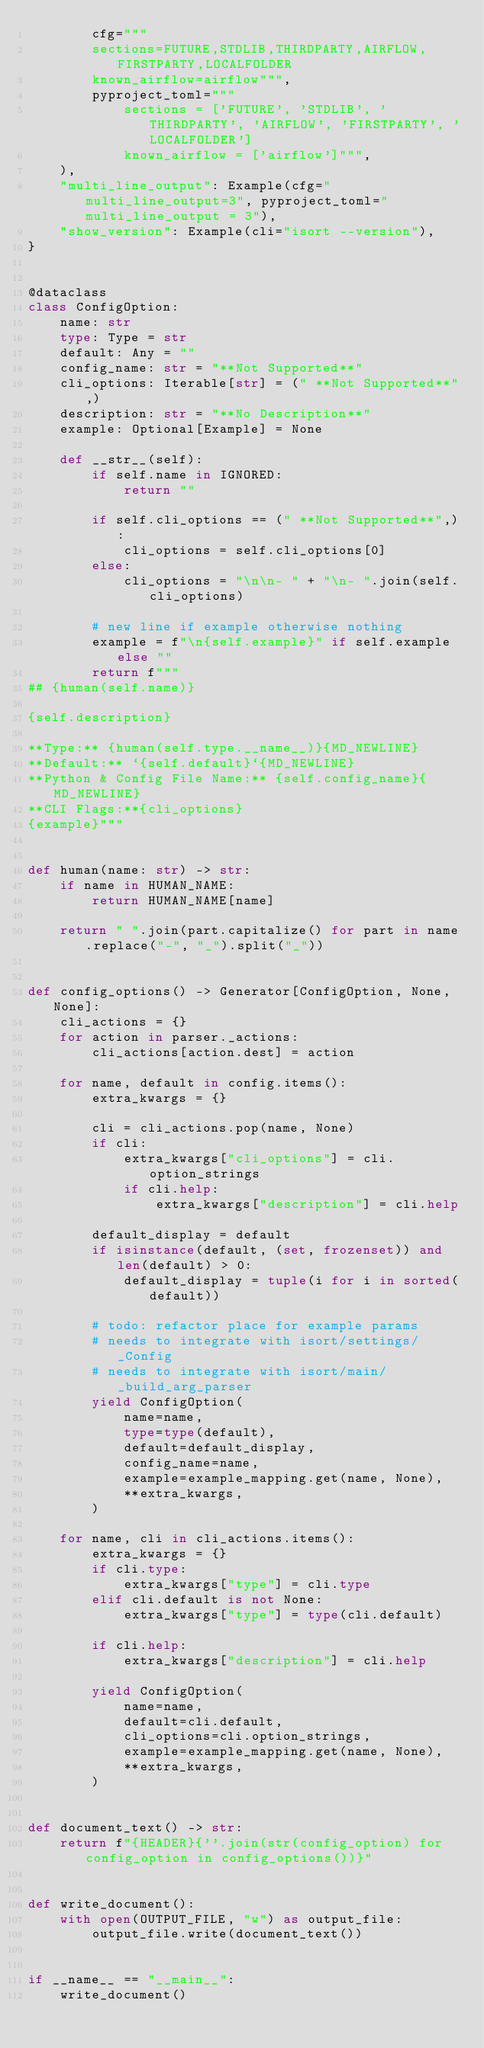<code> <loc_0><loc_0><loc_500><loc_500><_Python_>        cfg="""
        sections=FUTURE,STDLIB,THIRDPARTY,AIRFLOW,FIRSTPARTY,LOCALFOLDER
        known_airflow=airflow""",
        pyproject_toml="""
            sections = ['FUTURE', 'STDLIB', 'THIRDPARTY', 'AIRFLOW', 'FIRSTPARTY', 'LOCALFOLDER']
            known_airflow = ['airflow']""",
    ),
    "multi_line_output": Example(cfg="multi_line_output=3", pyproject_toml="multi_line_output = 3"),
    "show_version": Example(cli="isort --version"),
}


@dataclass
class ConfigOption:
    name: str
    type: Type = str
    default: Any = ""
    config_name: str = "**Not Supported**"
    cli_options: Iterable[str] = (" **Not Supported**",)
    description: str = "**No Description**"
    example: Optional[Example] = None

    def __str__(self):
        if self.name in IGNORED:
            return ""

        if self.cli_options == (" **Not Supported**",):
            cli_options = self.cli_options[0]
        else:
            cli_options = "\n\n- " + "\n- ".join(self.cli_options)

        # new line if example otherwise nothing
        example = f"\n{self.example}" if self.example else ""
        return f"""
## {human(self.name)}

{self.description}

**Type:** {human(self.type.__name__)}{MD_NEWLINE}
**Default:** `{self.default}`{MD_NEWLINE}
**Python & Config File Name:** {self.config_name}{MD_NEWLINE}
**CLI Flags:**{cli_options}
{example}"""


def human(name: str) -> str:
    if name in HUMAN_NAME:
        return HUMAN_NAME[name]

    return " ".join(part.capitalize() for part in name.replace("-", "_").split("_"))


def config_options() -> Generator[ConfigOption, None, None]:
    cli_actions = {}
    for action in parser._actions:
        cli_actions[action.dest] = action

    for name, default in config.items():
        extra_kwargs = {}

        cli = cli_actions.pop(name, None)
        if cli:
            extra_kwargs["cli_options"] = cli.option_strings
            if cli.help:
                extra_kwargs["description"] = cli.help

        default_display = default
        if isinstance(default, (set, frozenset)) and len(default) > 0:
            default_display = tuple(i for i in sorted(default))

        # todo: refactor place for example params
        # needs to integrate with isort/settings/_Config
        # needs to integrate with isort/main/_build_arg_parser
        yield ConfigOption(
            name=name,
            type=type(default),
            default=default_display,
            config_name=name,
            example=example_mapping.get(name, None),
            **extra_kwargs,
        )

    for name, cli in cli_actions.items():
        extra_kwargs = {}
        if cli.type:
            extra_kwargs["type"] = cli.type
        elif cli.default is not None:
            extra_kwargs["type"] = type(cli.default)

        if cli.help:
            extra_kwargs["description"] = cli.help

        yield ConfigOption(
            name=name,
            default=cli.default,
            cli_options=cli.option_strings,
            example=example_mapping.get(name, None),
            **extra_kwargs,
        )


def document_text() -> str:
    return f"{HEADER}{''.join(str(config_option) for config_option in config_options())}"


def write_document():
    with open(OUTPUT_FILE, "w") as output_file:
        output_file.write(document_text())


if __name__ == "__main__":
    write_document()
</code> 